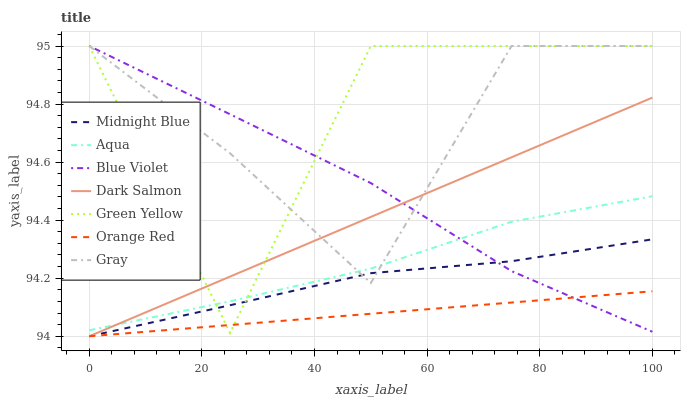Does Midnight Blue have the minimum area under the curve?
Answer yes or no. No. Does Midnight Blue have the maximum area under the curve?
Answer yes or no. No. Is Midnight Blue the smoothest?
Answer yes or no. No. Is Midnight Blue the roughest?
Answer yes or no. No. Does Aqua have the lowest value?
Answer yes or no. No. Does Midnight Blue have the highest value?
Answer yes or no. No. Is Midnight Blue less than Aqua?
Answer yes or no. Yes. Is Gray greater than Orange Red?
Answer yes or no. Yes. Does Midnight Blue intersect Aqua?
Answer yes or no. No. 